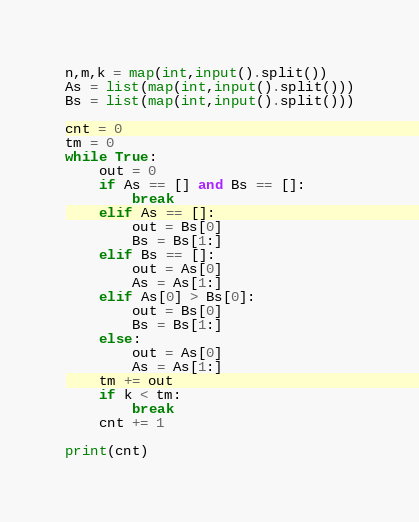Convert code to text. <code><loc_0><loc_0><loc_500><loc_500><_Python_>n,m,k = map(int,input().split())
As = list(map(int,input().split()))
Bs = list(map(int,input().split()))

cnt = 0
tm = 0 
while True:
    out = 0 
    if As == [] and Bs == []:
        break
    elif As == []:
        out = Bs[0]
        Bs = Bs[1:]
    elif Bs == []:
        out = As[0]
        As = As[1:]
    elif As[0] > Bs[0]:
        out = Bs[0]
        Bs = Bs[1:]
    else:
        out = As[0]
        As = As[1:]
    tm += out
    if k < tm:
        break
    cnt += 1

print(cnt)</code> 